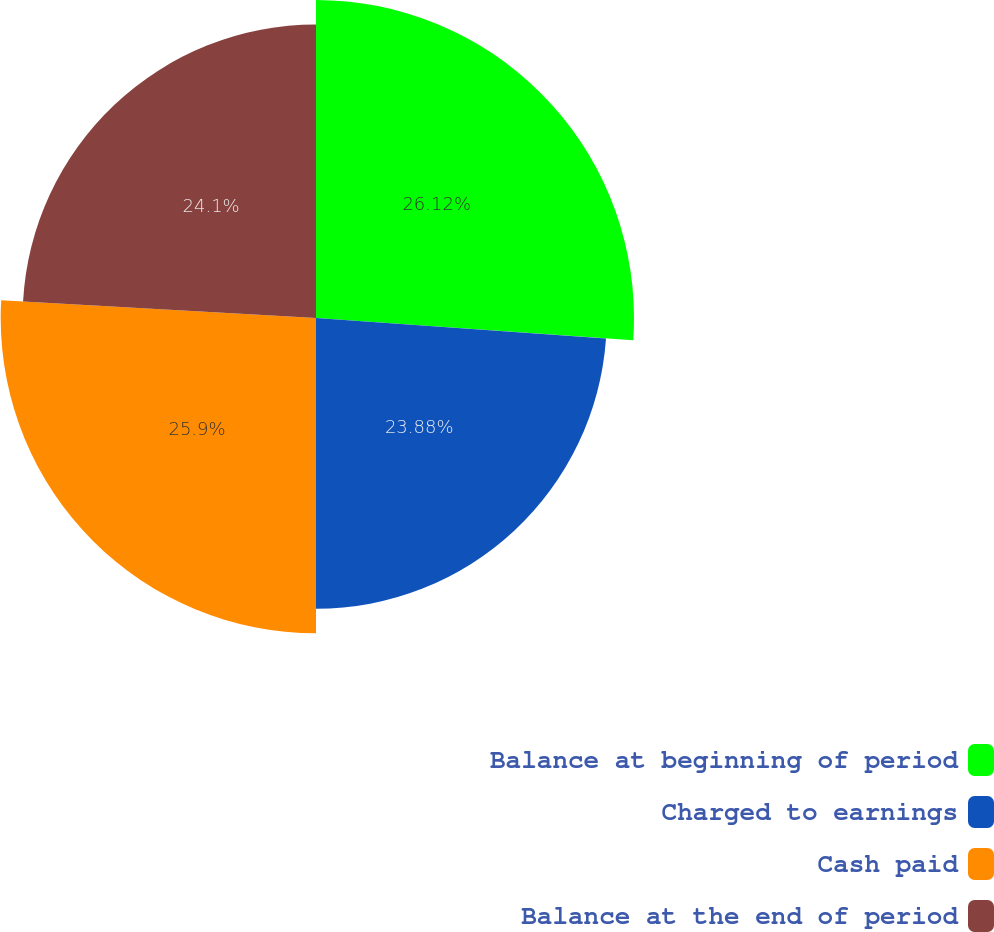<chart> <loc_0><loc_0><loc_500><loc_500><pie_chart><fcel>Balance at beginning of period<fcel>Charged to earnings<fcel>Cash paid<fcel>Balance at the end of period<nl><fcel>26.12%<fcel>23.88%<fcel>25.9%<fcel>24.1%<nl></chart> 